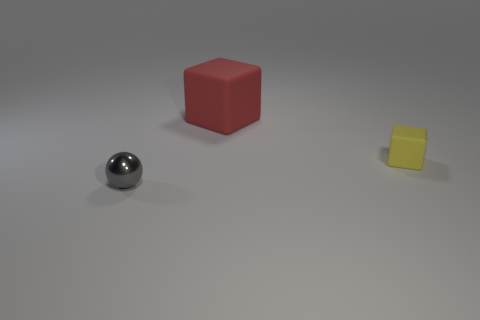Is there any other thing that is the same size as the red cube?
Your answer should be very brief. No. What number of large red blocks are to the left of the small sphere that is to the left of the tiny thing that is right of the gray ball?
Offer a very short reply. 0. There is a thing behind the rubber thing in front of the big red rubber thing; what color is it?
Provide a succinct answer. Red. Is there a cube that has the same size as the gray object?
Your answer should be compact. Yes. What material is the object that is behind the tiny object that is to the right of the tiny object that is on the left side of the tiny yellow object made of?
Give a very brief answer. Rubber. What number of objects are in front of the matte block that is in front of the big red cube?
Provide a short and direct response. 1. There is a object in front of the yellow thing; does it have the same size as the yellow block?
Offer a terse response. Yes. How many other large objects are the same shape as the shiny thing?
Offer a very short reply. 0. There is a big rubber thing; what shape is it?
Offer a very short reply. Cube. Are there an equal number of red objects in front of the small yellow matte thing and red rubber things?
Your answer should be compact. No. 